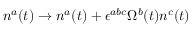Convert formula to latex. <formula><loc_0><loc_0><loc_500><loc_500>n ^ { a } ( t ) \rightarrow n ^ { a } ( t ) + \epsilon ^ { a b c } \Omega ^ { b } ( t ) n ^ { c } ( t )</formula> 